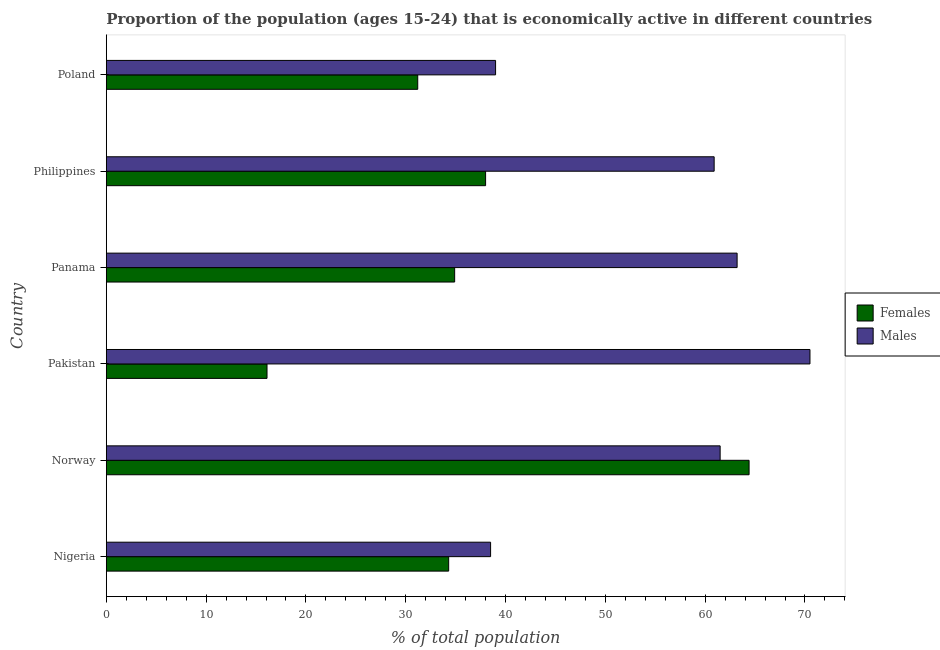How many different coloured bars are there?
Your answer should be very brief. 2. How many groups of bars are there?
Ensure brevity in your answer.  6. Are the number of bars per tick equal to the number of legend labels?
Offer a terse response. Yes. Are the number of bars on each tick of the Y-axis equal?
Offer a terse response. Yes. How many bars are there on the 6th tick from the bottom?
Provide a short and direct response. 2. What is the label of the 6th group of bars from the top?
Provide a short and direct response. Nigeria. In how many cases, is the number of bars for a given country not equal to the number of legend labels?
Offer a terse response. 0. What is the percentage of economically active female population in Pakistan?
Make the answer very short. 16.1. Across all countries, what is the maximum percentage of economically active male population?
Give a very brief answer. 70.5. Across all countries, what is the minimum percentage of economically active female population?
Offer a terse response. 16.1. What is the total percentage of economically active male population in the graph?
Your answer should be compact. 333.6. What is the difference between the percentage of economically active female population in Norway and that in Philippines?
Keep it short and to the point. 26.4. What is the difference between the percentage of economically active female population in Norway and the percentage of economically active male population in Poland?
Provide a short and direct response. 25.4. What is the average percentage of economically active female population per country?
Provide a succinct answer. 36.48. What is the difference between the percentage of economically active male population and percentage of economically active female population in Norway?
Provide a succinct answer. -2.9. In how many countries, is the percentage of economically active male population greater than 44 %?
Make the answer very short. 4. What is the ratio of the percentage of economically active male population in Philippines to that in Poland?
Offer a terse response. 1.56. Is the difference between the percentage of economically active male population in Philippines and Poland greater than the difference between the percentage of economically active female population in Philippines and Poland?
Your response must be concise. Yes. What is the difference between the highest and the second highest percentage of economically active male population?
Your response must be concise. 7.3. In how many countries, is the percentage of economically active female population greater than the average percentage of economically active female population taken over all countries?
Provide a short and direct response. 2. What does the 1st bar from the top in Philippines represents?
Make the answer very short. Males. What does the 2nd bar from the bottom in Philippines represents?
Keep it short and to the point. Males. Are all the bars in the graph horizontal?
Give a very brief answer. Yes. What is the difference between two consecutive major ticks on the X-axis?
Provide a succinct answer. 10. Does the graph contain grids?
Your response must be concise. No. Where does the legend appear in the graph?
Offer a terse response. Center right. What is the title of the graph?
Keep it short and to the point. Proportion of the population (ages 15-24) that is economically active in different countries. Does "State government" appear as one of the legend labels in the graph?
Provide a succinct answer. No. What is the label or title of the X-axis?
Make the answer very short. % of total population. What is the % of total population of Females in Nigeria?
Offer a very short reply. 34.3. What is the % of total population of Males in Nigeria?
Offer a terse response. 38.5. What is the % of total population in Females in Norway?
Offer a terse response. 64.4. What is the % of total population of Males in Norway?
Give a very brief answer. 61.5. What is the % of total population of Females in Pakistan?
Give a very brief answer. 16.1. What is the % of total population of Males in Pakistan?
Make the answer very short. 70.5. What is the % of total population in Females in Panama?
Give a very brief answer. 34.9. What is the % of total population of Males in Panama?
Offer a very short reply. 63.2. What is the % of total population in Females in Philippines?
Offer a very short reply. 38. What is the % of total population in Males in Philippines?
Offer a very short reply. 60.9. What is the % of total population in Females in Poland?
Ensure brevity in your answer.  31.2. What is the % of total population of Males in Poland?
Ensure brevity in your answer.  39. Across all countries, what is the maximum % of total population of Females?
Your response must be concise. 64.4. Across all countries, what is the maximum % of total population of Males?
Provide a succinct answer. 70.5. Across all countries, what is the minimum % of total population in Females?
Provide a short and direct response. 16.1. Across all countries, what is the minimum % of total population in Males?
Offer a terse response. 38.5. What is the total % of total population of Females in the graph?
Make the answer very short. 218.9. What is the total % of total population in Males in the graph?
Keep it short and to the point. 333.6. What is the difference between the % of total population of Females in Nigeria and that in Norway?
Give a very brief answer. -30.1. What is the difference between the % of total population of Males in Nigeria and that in Pakistan?
Ensure brevity in your answer.  -32. What is the difference between the % of total population of Males in Nigeria and that in Panama?
Give a very brief answer. -24.7. What is the difference between the % of total population in Females in Nigeria and that in Philippines?
Provide a short and direct response. -3.7. What is the difference between the % of total population of Males in Nigeria and that in Philippines?
Ensure brevity in your answer.  -22.4. What is the difference between the % of total population in Females in Norway and that in Pakistan?
Provide a succinct answer. 48.3. What is the difference between the % of total population in Females in Norway and that in Panama?
Give a very brief answer. 29.5. What is the difference between the % of total population in Males in Norway and that in Panama?
Offer a very short reply. -1.7. What is the difference between the % of total population of Females in Norway and that in Philippines?
Your response must be concise. 26.4. What is the difference between the % of total population of Females in Norway and that in Poland?
Provide a short and direct response. 33.2. What is the difference between the % of total population of Males in Norway and that in Poland?
Provide a short and direct response. 22.5. What is the difference between the % of total population in Females in Pakistan and that in Panama?
Offer a very short reply. -18.8. What is the difference between the % of total population of Females in Pakistan and that in Philippines?
Your answer should be very brief. -21.9. What is the difference between the % of total population of Females in Pakistan and that in Poland?
Provide a short and direct response. -15.1. What is the difference between the % of total population in Males in Pakistan and that in Poland?
Provide a succinct answer. 31.5. What is the difference between the % of total population in Females in Panama and that in Philippines?
Your answer should be very brief. -3.1. What is the difference between the % of total population of Males in Panama and that in Philippines?
Offer a terse response. 2.3. What is the difference between the % of total population in Females in Panama and that in Poland?
Your answer should be compact. 3.7. What is the difference between the % of total population of Males in Panama and that in Poland?
Your answer should be very brief. 24.2. What is the difference between the % of total population of Males in Philippines and that in Poland?
Offer a very short reply. 21.9. What is the difference between the % of total population in Females in Nigeria and the % of total population in Males in Norway?
Offer a terse response. -27.2. What is the difference between the % of total population of Females in Nigeria and the % of total population of Males in Pakistan?
Ensure brevity in your answer.  -36.2. What is the difference between the % of total population of Females in Nigeria and the % of total population of Males in Panama?
Offer a very short reply. -28.9. What is the difference between the % of total population of Females in Nigeria and the % of total population of Males in Philippines?
Provide a short and direct response. -26.6. What is the difference between the % of total population of Females in Norway and the % of total population of Males in Pakistan?
Ensure brevity in your answer.  -6.1. What is the difference between the % of total population in Females in Norway and the % of total population in Males in Philippines?
Provide a succinct answer. 3.5. What is the difference between the % of total population of Females in Norway and the % of total population of Males in Poland?
Offer a terse response. 25.4. What is the difference between the % of total population in Females in Pakistan and the % of total population in Males in Panama?
Your response must be concise. -47.1. What is the difference between the % of total population of Females in Pakistan and the % of total population of Males in Philippines?
Provide a short and direct response. -44.8. What is the difference between the % of total population in Females in Pakistan and the % of total population in Males in Poland?
Your answer should be compact. -22.9. What is the difference between the % of total population of Females in Panama and the % of total population of Males in Philippines?
Keep it short and to the point. -26. What is the average % of total population in Females per country?
Ensure brevity in your answer.  36.48. What is the average % of total population in Males per country?
Provide a short and direct response. 55.6. What is the difference between the % of total population of Females and % of total population of Males in Pakistan?
Provide a short and direct response. -54.4. What is the difference between the % of total population of Females and % of total population of Males in Panama?
Offer a terse response. -28.3. What is the difference between the % of total population of Females and % of total population of Males in Philippines?
Your response must be concise. -22.9. What is the difference between the % of total population in Females and % of total population in Males in Poland?
Offer a terse response. -7.8. What is the ratio of the % of total population of Females in Nigeria to that in Norway?
Make the answer very short. 0.53. What is the ratio of the % of total population in Males in Nigeria to that in Norway?
Provide a succinct answer. 0.63. What is the ratio of the % of total population in Females in Nigeria to that in Pakistan?
Offer a terse response. 2.13. What is the ratio of the % of total population in Males in Nigeria to that in Pakistan?
Your answer should be compact. 0.55. What is the ratio of the % of total population in Females in Nigeria to that in Panama?
Provide a succinct answer. 0.98. What is the ratio of the % of total population in Males in Nigeria to that in Panama?
Ensure brevity in your answer.  0.61. What is the ratio of the % of total population in Females in Nigeria to that in Philippines?
Provide a short and direct response. 0.9. What is the ratio of the % of total population of Males in Nigeria to that in Philippines?
Your answer should be very brief. 0.63. What is the ratio of the % of total population of Females in Nigeria to that in Poland?
Ensure brevity in your answer.  1.1. What is the ratio of the % of total population in Males in Nigeria to that in Poland?
Your response must be concise. 0.99. What is the ratio of the % of total population of Females in Norway to that in Pakistan?
Provide a succinct answer. 4. What is the ratio of the % of total population in Males in Norway to that in Pakistan?
Provide a succinct answer. 0.87. What is the ratio of the % of total population in Females in Norway to that in Panama?
Keep it short and to the point. 1.85. What is the ratio of the % of total population of Males in Norway to that in Panama?
Provide a short and direct response. 0.97. What is the ratio of the % of total population in Females in Norway to that in Philippines?
Make the answer very short. 1.69. What is the ratio of the % of total population in Males in Norway to that in Philippines?
Your answer should be very brief. 1.01. What is the ratio of the % of total population in Females in Norway to that in Poland?
Provide a succinct answer. 2.06. What is the ratio of the % of total population of Males in Norway to that in Poland?
Your response must be concise. 1.58. What is the ratio of the % of total population in Females in Pakistan to that in Panama?
Your answer should be very brief. 0.46. What is the ratio of the % of total population of Males in Pakistan to that in Panama?
Ensure brevity in your answer.  1.12. What is the ratio of the % of total population of Females in Pakistan to that in Philippines?
Make the answer very short. 0.42. What is the ratio of the % of total population in Males in Pakistan to that in Philippines?
Your answer should be compact. 1.16. What is the ratio of the % of total population in Females in Pakistan to that in Poland?
Make the answer very short. 0.52. What is the ratio of the % of total population of Males in Pakistan to that in Poland?
Keep it short and to the point. 1.81. What is the ratio of the % of total population of Females in Panama to that in Philippines?
Offer a very short reply. 0.92. What is the ratio of the % of total population in Males in Panama to that in Philippines?
Ensure brevity in your answer.  1.04. What is the ratio of the % of total population in Females in Panama to that in Poland?
Ensure brevity in your answer.  1.12. What is the ratio of the % of total population of Males in Panama to that in Poland?
Keep it short and to the point. 1.62. What is the ratio of the % of total population of Females in Philippines to that in Poland?
Keep it short and to the point. 1.22. What is the ratio of the % of total population in Males in Philippines to that in Poland?
Provide a short and direct response. 1.56. What is the difference between the highest and the second highest % of total population of Females?
Provide a short and direct response. 26.4. What is the difference between the highest and the second highest % of total population in Males?
Give a very brief answer. 7.3. What is the difference between the highest and the lowest % of total population in Females?
Your answer should be compact. 48.3. 